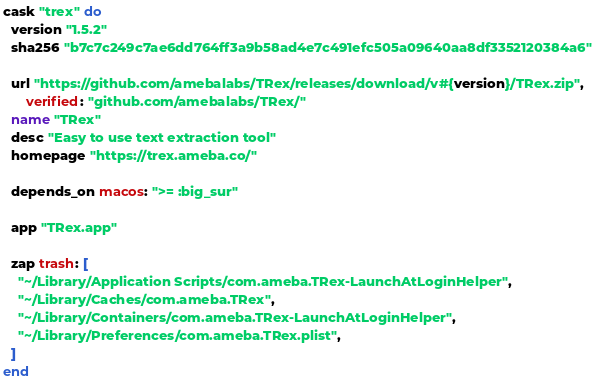Convert code to text. <code><loc_0><loc_0><loc_500><loc_500><_Ruby_>cask "trex" do
  version "1.5.2"
  sha256 "b7c7c249c7ae6dd764ff3a9b58ad4e7c491efc505a09640aa8df3352120384a6"

  url "https://github.com/amebalabs/TRex/releases/download/v#{version}/TRex.zip",
      verified: "github.com/amebalabs/TRex/"
  name "TRex"
  desc "Easy to use text extraction tool"
  homepage "https://trex.ameba.co/"

  depends_on macos: ">= :big_sur"

  app "TRex.app"

  zap trash: [
    "~/Library/Application Scripts/com.ameba.TRex-LaunchAtLoginHelper",
    "~/Library/Caches/com.ameba.TRex",
    "~/Library/Containers/com.ameba.TRex-LaunchAtLoginHelper",
    "~/Library/Preferences/com.ameba.TRex.plist",
  ]
end
</code> 